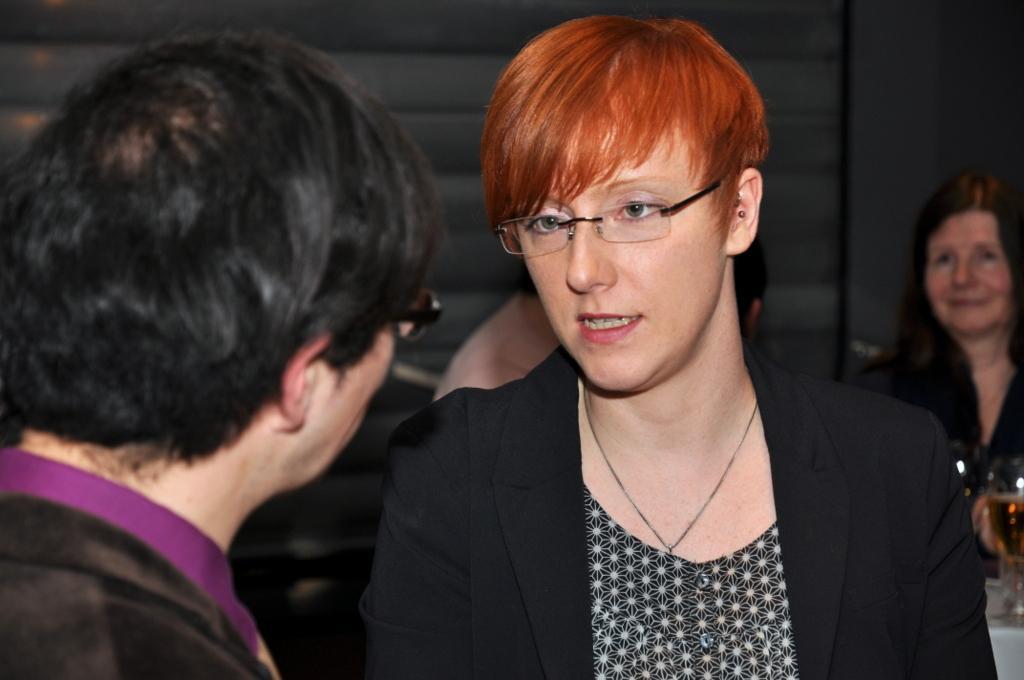Describe this image in one or two sentences. In this image there are group of people , glasses on the table, wall. 